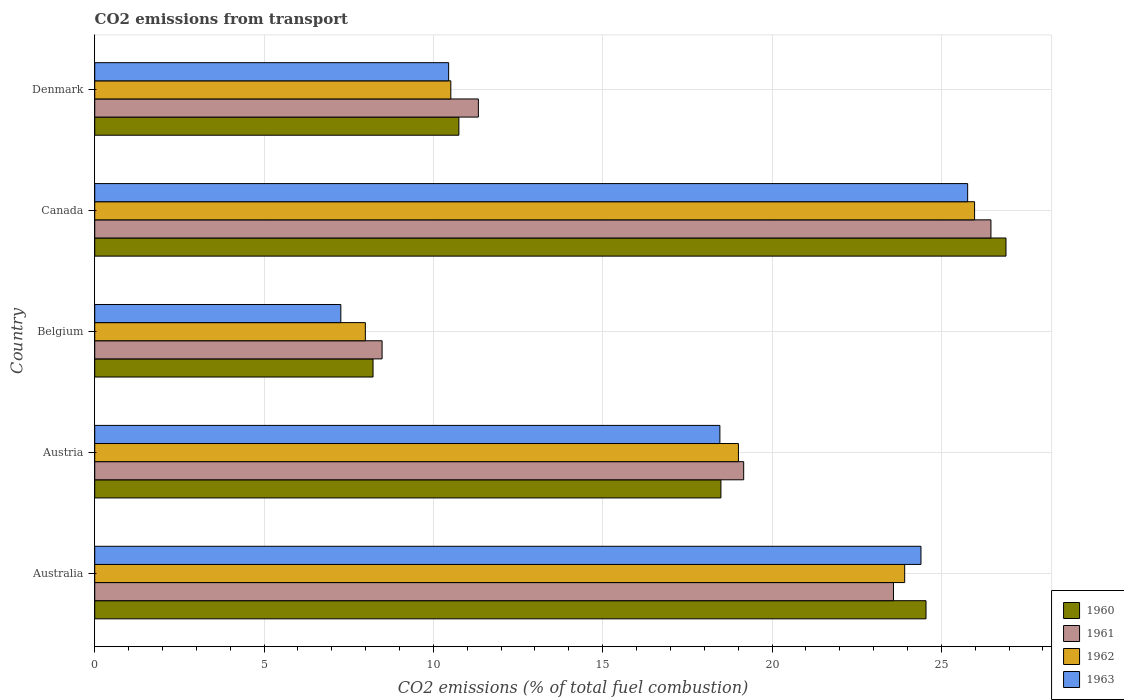How many groups of bars are there?
Your answer should be very brief. 5. Are the number of bars per tick equal to the number of legend labels?
Offer a terse response. Yes. Are the number of bars on each tick of the Y-axis equal?
Offer a terse response. Yes. How many bars are there on the 3rd tick from the top?
Provide a short and direct response. 4. What is the label of the 1st group of bars from the top?
Provide a succinct answer. Denmark. In how many cases, is the number of bars for a given country not equal to the number of legend labels?
Your answer should be compact. 0. What is the total CO2 emitted in 1961 in Australia?
Give a very brief answer. 23.59. Across all countries, what is the maximum total CO2 emitted in 1963?
Your answer should be very brief. 25.78. Across all countries, what is the minimum total CO2 emitted in 1960?
Ensure brevity in your answer.  8.22. In which country was the total CO2 emitted in 1962 maximum?
Provide a short and direct response. Canada. In which country was the total CO2 emitted in 1961 minimum?
Make the answer very short. Belgium. What is the total total CO2 emitted in 1962 in the graph?
Your answer should be very brief. 87.41. What is the difference between the total CO2 emitted in 1961 in Australia and that in Denmark?
Your answer should be very brief. 12.26. What is the difference between the total CO2 emitted in 1963 in Austria and the total CO2 emitted in 1961 in Denmark?
Offer a very short reply. 7.13. What is the average total CO2 emitted in 1962 per country?
Provide a short and direct response. 17.48. What is the difference between the total CO2 emitted in 1961 and total CO2 emitted in 1960 in Austria?
Your answer should be compact. 0.67. In how many countries, is the total CO2 emitted in 1960 greater than 6 ?
Keep it short and to the point. 5. What is the ratio of the total CO2 emitted in 1961 in Australia to that in Denmark?
Offer a terse response. 2.08. Is the total CO2 emitted in 1962 in Australia less than that in Denmark?
Keep it short and to the point. No. What is the difference between the highest and the second highest total CO2 emitted in 1963?
Your answer should be very brief. 1.38. What is the difference between the highest and the lowest total CO2 emitted in 1961?
Offer a very short reply. 17.98. Is the sum of the total CO2 emitted in 1960 in Australia and Austria greater than the maximum total CO2 emitted in 1961 across all countries?
Offer a terse response. Yes. What does the 4th bar from the top in Austria represents?
Your response must be concise. 1960. Is it the case that in every country, the sum of the total CO2 emitted in 1962 and total CO2 emitted in 1960 is greater than the total CO2 emitted in 1963?
Your response must be concise. Yes. How many bars are there?
Offer a very short reply. 20. Are all the bars in the graph horizontal?
Provide a short and direct response. Yes. How many countries are there in the graph?
Offer a very short reply. 5. How many legend labels are there?
Provide a succinct answer. 4. What is the title of the graph?
Ensure brevity in your answer.  CO2 emissions from transport. Does "1968" appear as one of the legend labels in the graph?
Your response must be concise. No. What is the label or title of the X-axis?
Give a very brief answer. CO2 emissions (% of total fuel combustion). What is the CO2 emissions (% of total fuel combustion) in 1960 in Australia?
Make the answer very short. 24.55. What is the CO2 emissions (% of total fuel combustion) of 1961 in Australia?
Give a very brief answer. 23.59. What is the CO2 emissions (% of total fuel combustion) in 1962 in Australia?
Ensure brevity in your answer.  23.92. What is the CO2 emissions (% of total fuel combustion) in 1963 in Australia?
Ensure brevity in your answer.  24.4. What is the CO2 emissions (% of total fuel combustion) of 1960 in Austria?
Provide a succinct answer. 18.49. What is the CO2 emissions (% of total fuel combustion) of 1961 in Austria?
Your answer should be compact. 19.16. What is the CO2 emissions (% of total fuel combustion) of 1962 in Austria?
Your answer should be compact. 19.01. What is the CO2 emissions (% of total fuel combustion) in 1963 in Austria?
Make the answer very short. 18.46. What is the CO2 emissions (% of total fuel combustion) of 1960 in Belgium?
Keep it short and to the point. 8.22. What is the CO2 emissions (% of total fuel combustion) of 1961 in Belgium?
Your answer should be very brief. 8.49. What is the CO2 emissions (% of total fuel combustion) in 1962 in Belgium?
Your answer should be compact. 7.99. What is the CO2 emissions (% of total fuel combustion) in 1963 in Belgium?
Offer a terse response. 7.27. What is the CO2 emissions (% of total fuel combustion) of 1960 in Canada?
Your response must be concise. 26.91. What is the CO2 emissions (% of total fuel combustion) in 1961 in Canada?
Offer a terse response. 26.46. What is the CO2 emissions (% of total fuel combustion) in 1962 in Canada?
Provide a succinct answer. 25.98. What is the CO2 emissions (% of total fuel combustion) of 1963 in Canada?
Make the answer very short. 25.78. What is the CO2 emissions (% of total fuel combustion) of 1960 in Denmark?
Give a very brief answer. 10.75. What is the CO2 emissions (% of total fuel combustion) in 1961 in Denmark?
Offer a terse response. 11.33. What is the CO2 emissions (% of total fuel combustion) of 1962 in Denmark?
Your answer should be very brief. 10.51. What is the CO2 emissions (% of total fuel combustion) in 1963 in Denmark?
Your answer should be very brief. 10.45. Across all countries, what is the maximum CO2 emissions (% of total fuel combustion) in 1960?
Keep it short and to the point. 26.91. Across all countries, what is the maximum CO2 emissions (% of total fuel combustion) in 1961?
Offer a terse response. 26.46. Across all countries, what is the maximum CO2 emissions (% of total fuel combustion) of 1962?
Offer a terse response. 25.98. Across all countries, what is the maximum CO2 emissions (% of total fuel combustion) of 1963?
Make the answer very short. 25.78. Across all countries, what is the minimum CO2 emissions (% of total fuel combustion) of 1960?
Your answer should be compact. 8.22. Across all countries, what is the minimum CO2 emissions (% of total fuel combustion) in 1961?
Keep it short and to the point. 8.49. Across all countries, what is the minimum CO2 emissions (% of total fuel combustion) of 1962?
Ensure brevity in your answer.  7.99. Across all countries, what is the minimum CO2 emissions (% of total fuel combustion) of 1963?
Keep it short and to the point. 7.27. What is the total CO2 emissions (% of total fuel combustion) of 1960 in the graph?
Offer a very short reply. 88.91. What is the total CO2 emissions (% of total fuel combustion) of 1961 in the graph?
Offer a terse response. 89.02. What is the total CO2 emissions (% of total fuel combustion) of 1962 in the graph?
Offer a very short reply. 87.41. What is the total CO2 emissions (% of total fuel combustion) in 1963 in the graph?
Offer a terse response. 86.35. What is the difference between the CO2 emissions (% of total fuel combustion) of 1960 in Australia and that in Austria?
Your response must be concise. 6.06. What is the difference between the CO2 emissions (% of total fuel combustion) of 1961 in Australia and that in Austria?
Give a very brief answer. 4.42. What is the difference between the CO2 emissions (% of total fuel combustion) in 1962 in Australia and that in Austria?
Offer a terse response. 4.91. What is the difference between the CO2 emissions (% of total fuel combustion) of 1963 in Australia and that in Austria?
Your response must be concise. 5.94. What is the difference between the CO2 emissions (% of total fuel combustion) in 1960 in Australia and that in Belgium?
Offer a terse response. 16.33. What is the difference between the CO2 emissions (% of total fuel combustion) in 1961 in Australia and that in Belgium?
Give a very brief answer. 15.1. What is the difference between the CO2 emissions (% of total fuel combustion) of 1962 in Australia and that in Belgium?
Offer a terse response. 15.93. What is the difference between the CO2 emissions (% of total fuel combustion) in 1963 in Australia and that in Belgium?
Keep it short and to the point. 17.13. What is the difference between the CO2 emissions (% of total fuel combustion) of 1960 in Australia and that in Canada?
Provide a short and direct response. -2.36. What is the difference between the CO2 emissions (% of total fuel combustion) in 1961 in Australia and that in Canada?
Keep it short and to the point. -2.88. What is the difference between the CO2 emissions (% of total fuel combustion) in 1962 in Australia and that in Canada?
Your response must be concise. -2.06. What is the difference between the CO2 emissions (% of total fuel combustion) in 1963 in Australia and that in Canada?
Keep it short and to the point. -1.38. What is the difference between the CO2 emissions (% of total fuel combustion) in 1960 in Australia and that in Denmark?
Make the answer very short. 13.79. What is the difference between the CO2 emissions (% of total fuel combustion) of 1961 in Australia and that in Denmark?
Give a very brief answer. 12.26. What is the difference between the CO2 emissions (% of total fuel combustion) in 1962 in Australia and that in Denmark?
Your answer should be compact. 13.4. What is the difference between the CO2 emissions (% of total fuel combustion) in 1963 in Australia and that in Denmark?
Your answer should be compact. 13.95. What is the difference between the CO2 emissions (% of total fuel combustion) of 1960 in Austria and that in Belgium?
Provide a succinct answer. 10.27. What is the difference between the CO2 emissions (% of total fuel combustion) of 1961 in Austria and that in Belgium?
Keep it short and to the point. 10.68. What is the difference between the CO2 emissions (% of total fuel combustion) in 1962 in Austria and that in Belgium?
Your response must be concise. 11.02. What is the difference between the CO2 emissions (% of total fuel combustion) of 1963 in Austria and that in Belgium?
Make the answer very short. 11.19. What is the difference between the CO2 emissions (% of total fuel combustion) of 1960 in Austria and that in Canada?
Provide a short and direct response. -8.42. What is the difference between the CO2 emissions (% of total fuel combustion) of 1961 in Austria and that in Canada?
Offer a terse response. -7.3. What is the difference between the CO2 emissions (% of total fuel combustion) in 1962 in Austria and that in Canada?
Keep it short and to the point. -6.97. What is the difference between the CO2 emissions (% of total fuel combustion) in 1963 in Austria and that in Canada?
Make the answer very short. -7.32. What is the difference between the CO2 emissions (% of total fuel combustion) of 1960 in Austria and that in Denmark?
Keep it short and to the point. 7.74. What is the difference between the CO2 emissions (% of total fuel combustion) in 1961 in Austria and that in Denmark?
Give a very brief answer. 7.83. What is the difference between the CO2 emissions (% of total fuel combustion) of 1962 in Austria and that in Denmark?
Make the answer very short. 8.49. What is the difference between the CO2 emissions (% of total fuel combustion) of 1963 in Austria and that in Denmark?
Offer a terse response. 8.01. What is the difference between the CO2 emissions (% of total fuel combustion) of 1960 in Belgium and that in Canada?
Your answer should be compact. -18.69. What is the difference between the CO2 emissions (% of total fuel combustion) in 1961 in Belgium and that in Canada?
Your response must be concise. -17.98. What is the difference between the CO2 emissions (% of total fuel combustion) of 1962 in Belgium and that in Canada?
Give a very brief answer. -17.99. What is the difference between the CO2 emissions (% of total fuel combustion) of 1963 in Belgium and that in Canada?
Keep it short and to the point. -18.51. What is the difference between the CO2 emissions (% of total fuel combustion) in 1960 in Belgium and that in Denmark?
Provide a succinct answer. -2.53. What is the difference between the CO2 emissions (% of total fuel combustion) of 1961 in Belgium and that in Denmark?
Your response must be concise. -2.84. What is the difference between the CO2 emissions (% of total fuel combustion) in 1962 in Belgium and that in Denmark?
Provide a succinct answer. -2.52. What is the difference between the CO2 emissions (% of total fuel combustion) in 1963 in Belgium and that in Denmark?
Provide a succinct answer. -3.18. What is the difference between the CO2 emissions (% of total fuel combustion) of 1960 in Canada and that in Denmark?
Your response must be concise. 16.16. What is the difference between the CO2 emissions (% of total fuel combustion) in 1961 in Canada and that in Denmark?
Keep it short and to the point. 15.13. What is the difference between the CO2 emissions (% of total fuel combustion) of 1962 in Canada and that in Denmark?
Your answer should be very brief. 15.47. What is the difference between the CO2 emissions (% of total fuel combustion) in 1963 in Canada and that in Denmark?
Offer a very short reply. 15.33. What is the difference between the CO2 emissions (% of total fuel combustion) in 1960 in Australia and the CO2 emissions (% of total fuel combustion) in 1961 in Austria?
Your response must be concise. 5.38. What is the difference between the CO2 emissions (% of total fuel combustion) in 1960 in Australia and the CO2 emissions (% of total fuel combustion) in 1962 in Austria?
Offer a very short reply. 5.54. What is the difference between the CO2 emissions (% of total fuel combustion) of 1960 in Australia and the CO2 emissions (% of total fuel combustion) of 1963 in Austria?
Offer a very short reply. 6.09. What is the difference between the CO2 emissions (% of total fuel combustion) in 1961 in Australia and the CO2 emissions (% of total fuel combustion) in 1962 in Austria?
Keep it short and to the point. 4.58. What is the difference between the CO2 emissions (% of total fuel combustion) of 1961 in Australia and the CO2 emissions (% of total fuel combustion) of 1963 in Austria?
Offer a very short reply. 5.13. What is the difference between the CO2 emissions (% of total fuel combustion) of 1962 in Australia and the CO2 emissions (% of total fuel combustion) of 1963 in Austria?
Offer a very short reply. 5.46. What is the difference between the CO2 emissions (% of total fuel combustion) of 1960 in Australia and the CO2 emissions (% of total fuel combustion) of 1961 in Belgium?
Keep it short and to the point. 16.06. What is the difference between the CO2 emissions (% of total fuel combustion) in 1960 in Australia and the CO2 emissions (% of total fuel combustion) in 1962 in Belgium?
Give a very brief answer. 16.56. What is the difference between the CO2 emissions (% of total fuel combustion) of 1960 in Australia and the CO2 emissions (% of total fuel combustion) of 1963 in Belgium?
Your answer should be compact. 17.28. What is the difference between the CO2 emissions (% of total fuel combustion) of 1961 in Australia and the CO2 emissions (% of total fuel combustion) of 1962 in Belgium?
Your response must be concise. 15.59. What is the difference between the CO2 emissions (% of total fuel combustion) in 1961 in Australia and the CO2 emissions (% of total fuel combustion) in 1963 in Belgium?
Make the answer very short. 16.32. What is the difference between the CO2 emissions (% of total fuel combustion) in 1962 in Australia and the CO2 emissions (% of total fuel combustion) in 1963 in Belgium?
Ensure brevity in your answer.  16.65. What is the difference between the CO2 emissions (% of total fuel combustion) in 1960 in Australia and the CO2 emissions (% of total fuel combustion) in 1961 in Canada?
Ensure brevity in your answer.  -1.92. What is the difference between the CO2 emissions (% of total fuel combustion) of 1960 in Australia and the CO2 emissions (% of total fuel combustion) of 1962 in Canada?
Provide a succinct answer. -1.43. What is the difference between the CO2 emissions (% of total fuel combustion) of 1960 in Australia and the CO2 emissions (% of total fuel combustion) of 1963 in Canada?
Provide a succinct answer. -1.23. What is the difference between the CO2 emissions (% of total fuel combustion) of 1961 in Australia and the CO2 emissions (% of total fuel combustion) of 1962 in Canada?
Make the answer very short. -2.4. What is the difference between the CO2 emissions (% of total fuel combustion) in 1961 in Australia and the CO2 emissions (% of total fuel combustion) in 1963 in Canada?
Provide a succinct answer. -2.19. What is the difference between the CO2 emissions (% of total fuel combustion) in 1962 in Australia and the CO2 emissions (% of total fuel combustion) in 1963 in Canada?
Ensure brevity in your answer.  -1.86. What is the difference between the CO2 emissions (% of total fuel combustion) of 1960 in Australia and the CO2 emissions (% of total fuel combustion) of 1961 in Denmark?
Make the answer very short. 13.22. What is the difference between the CO2 emissions (% of total fuel combustion) in 1960 in Australia and the CO2 emissions (% of total fuel combustion) in 1962 in Denmark?
Provide a succinct answer. 14.03. What is the difference between the CO2 emissions (% of total fuel combustion) in 1960 in Australia and the CO2 emissions (% of total fuel combustion) in 1963 in Denmark?
Ensure brevity in your answer.  14.1. What is the difference between the CO2 emissions (% of total fuel combustion) in 1961 in Australia and the CO2 emissions (% of total fuel combustion) in 1962 in Denmark?
Your response must be concise. 13.07. What is the difference between the CO2 emissions (% of total fuel combustion) of 1961 in Australia and the CO2 emissions (% of total fuel combustion) of 1963 in Denmark?
Your answer should be compact. 13.13. What is the difference between the CO2 emissions (% of total fuel combustion) of 1962 in Australia and the CO2 emissions (% of total fuel combustion) of 1963 in Denmark?
Your answer should be compact. 13.47. What is the difference between the CO2 emissions (% of total fuel combustion) of 1960 in Austria and the CO2 emissions (% of total fuel combustion) of 1961 in Belgium?
Offer a terse response. 10. What is the difference between the CO2 emissions (% of total fuel combustion) in 1960 in Austria and the CO2 emissions (% of total fuel combustion) in 1962 in Belgium?
Give a very brief answer. 10.5. What is the difference between the CO2 emissions (% of total fuel combustion) of 1960 in Austria and the CO2 emissions (% of total fuel combustion) of 1963 in Belgium?
Provide a succinct answer. 11.22. What is the difference between the CO2 emissions (% of total fuel combustion) of 1961 in Austria and the CO2 emissions (% of total fuel combustion) of 1962 in Belgium?
Offer a very short reply. 11.17. What is the difference between the CO2 emissions (% of total fuel combustion) of 1961 in Austria and the CO2 emissions (% of total fuel combustion) of 1963 in Belgium?
Keep it short and to the point. 11.9. What is the difference between the CO2 emissions (% of total fuel combustion) in 1962 in Austria and the CO2 emissions (% of total fuel combustion) in 1963 in Belgium?
Provide a short and direct response. 11.74. What is the difference between the CO2 emissions (% of total fuel combustion) in 1960 in Austria and the CO2 emissions (% of total fuel combustion) in 1961 in Canada?
Provide a succinct answer. -7.97. What is the difference between the CO2 emissions (% of total fuel combustion) in 1960 in Austria and the CO2 emissions (% of total fuel combustion) in 1962 in Canada?
Provide a succinct answer. -7.49. What is the difference between the CO2 emissions (% of total fuel combustion) of 1960 in Austria and the CO2 emissions (% of total fuel combustion) of 1963 in Canada?
Your answer should be compact. -7.29. What is the difference between the CO2 emissions (% of total fuel combustion) in 1961 in Austria and the CO2 emissions (% of total fuel combustion) in 1962 in Canada?
Give a very brief answer. -6.82. What is the difference between the CO2 emissions (% of total fuel combustion) of 1961 in Austria and the CO2 emissions (% of total fuel combustion) of 1963 in Canada?
Offer a very short reply. -6.61. What is the difference between the CO2 emissions (% of total fuel combustion) in 1962 in Austria and the CO2 emissions (% of total fuel combustion) in 1963 in Canada?
Give a very brief answer. -6.77. What is the difference between the CO2 emissions (% of total fuel combustion) of 1960 in Austria and the CO2 emissions (% of total fuel combustion) of 1961 in Denmark?
Your answer should be very brief. 7.16. What is the difference between the CO2 emissions (% of total fuel combustion) in 1960 in Austria and the CO2 emissions (% of total fuel combustion) in 1962 in Denmark?
Give a very brief answer. 7.98. What is the difference between the CO2 emissions (% of total fuel combustion) in 1960 in Austria and the CO2 emissions (% of total fuel combustion) in 1963 in Denmark?
Make the answer very short. 8.04. What is the difference between the CO2 emissions (% of total fuel combustion) of 1961 in Austria and the CO2 emissions (% of total fuel combustion) of 1962 in Denmark?
Offer a very short reply. 8.65. What is the difference between the CO2 emissions (% of total fuel combustion) of 1961 in Austria and the CO2 emissions (% of total fuel combustion) of 1963 in Denmark?
Make the answer very short. 8.71. What is the difference between the CO2 emissions (% of total fuel combustion) of 1962 in Austria and the CO2 emissions (% of total fuel combustion) of 1963 in Denmark?
Give a very brief answer. 8.56. What is the difference between the CO2 emissions (% of total fuel combustion) in 1960 in Belgium and the CO2 emissions (% of total fuel combustion) in 1961 in Canada?
Ensure brevity in your answer.  -18.25. What is the difference between the CO2 emissions (% of total fuel combustion) of 1960 in Belgium and the CO2 emissions (% of total fuel combustion) of 1962 in Canada?
Your response must be concise. -17.76. What is the difference between the CO2 emissions (% of total fuel combustion) of 1960 in Belgium and the CO2 emissions (% of total fuel combustion) of 1963 in Canada?
Offer a very short reply. -17.56. What is the difference between the CO2 emissions (% of total fuel combustion) in 1961 in Belgium and the CO2 emissions (% of total fuel combustion) in 1962 in Canada?
Keep it short and to the point. -17.5. What is the difference between the CO2 emissions (% of total fuel combustion) in 1961 in Belgium and the CO2 emissions (% of total fuel combustion) in 1963 in Canada?
Keep it short and to the point. -17.29. What is the difference between the CO2 emissions (% of total fuel combustion) of 1962 in Belgium and the CO2 emissions (% of total fuel combustion) of 1963 in Canada?
Your answer should be compact. -17.79. What is the difference between the CO2 emissions (% of total fuel combustion) of 1960 in Belgium and the CO2 emissions (% of total fuel combustion) of 1961 in Denmark?
Offer a very short reply. -3.11. What is the difference between the CO2 emissions (% of total fuel combustion) of 1960 in Belgium and the CO2 emissions (% of total fuel combustion) of 1962 in Denmark?
Your answer should be very brief. -2.3. What is the difference between the CO2 emissions (% of total fuel combustion) in 1960 in Belgium and the CO2 emissions (% of total fuel combustion) in 1963 in Denmark?
Your response must be concise. -2.23. What is the difference between the CO2 emissions (% of total fuel combustion) in 1961 in Belgium and the CO2 emissions (% of total fuel combustion) in 1962 in Denmark?
Keep it short and to the point. -2.03. What is the difference between the CO2 emissions (% of total fuel combustion) of 1961 in Belgium and the CO2 emissions (% of total fuel combustion) of 1963 in Denmark?
Offer a terse response. -1.96. What is the difference between the CO2 emissions (% of total fuel combustion) in 1962 in Belgium and the CO2 emissions (% of total fuel combustion) in 1963 in Denmark?
Ensure brevity in your answer.  -2.46. What is the difference between the CO2 emissions (% of total fuel combustion) in 1960 in Canada and the CO2 emissions (% of total fuel combustion) in 1961 in Denmark?
Offer a terse response. 15.58. What is the difference between the CO2 emissions (% of total fuel combustion) of 1960 in Canada and the CO2 emissions (% of total fuel combustion) of 1962 in Denmark?
Provide a short and direct response. 16.39. What is the difference between the CO2 emissions (% of total fuel combustion) in 1960 in Canada and the CO2 emissions (% of total fuel combustion) in 1963 in Denmark?
Offer a terse response. 16.46. What is the difference between the CO2 emissions (% of total fuel combustion) of 1961 in Canada and the CO2 emissions (% of total fuel combustion) of 1962 in Denmark?
Offer a terse response. 15.95. What is the difference between the CO2 emissions (% of total fuel combustion) of 1961 in Canada and the CO2 emissions (% of total fuel combustion) of 1963 in Denmark?
Provide a short and direct response. 16.01. What is the difference between the CO2 emissions (% of total fuel combustion) of 1962 in Canada and the CO2 emissions (% of total fuel combustion) of 1963 in Denmark?
Keep it short and to the point. 15.53. What is the average CO2 emissions (% of total fuel combustion) of 1960 per country?
Offer a terse response. 17.78. What is the average CO2 emissions (% of total fuel combustion) in 1961 per country?
Give a very brief answer. 17.8. What is the average CO2 emissions (% of total fuel combustion) in 1962 per country?
Your answer should be very brief. 17.48. What is the average CO2 emissions (% of total fuel combustion) of 1963 per country?
Ensure brevity in your answer.  17.27. What is the difference between the CO2 emissions (% of total fuel combustion) of 1960 and CO2 emissions (% of total fuel combustion) of 1961 in Australia?
Offer a very short reply. 0.96. What is the difference between the CO2 emissions (% of total fuel combustion) in 1960 and CO2 emissions (% of total fuel combustion) in 1962 in Australia?
Provide a short and direct response. 0.63. What is the difference between the CO2 emissions (% of total fuel combustion) of 1960 and CO2 emissions (% of total fuel combustion) of 1963 in Australia?
Provide a short and direct response. 0.15. What is the difference between the CO2 emissions (% of total fuel combustion) in 1961 and CO2 emissions (% of total fuel combustion) in 1962 in Australia?
Your answer should be compact. -0.33. What is the difference between the CO2 emissions (% of total fuel combustion) of 1961 and CO2 emissions (% of total fuel combustion) of 1963 in Australia?
Provide a short and direct response. -0.81. What is the difference between the CO2 emissions (% of total fuel combustion) of 1962 and CO2 emissions (% of total fuel combustion) of 1963 in Australia?
Provide a short and direct response. -0.48. What is the difference between the CO2 emissions (% of total fuel combustion) in 1960 and CO2 emissions (% of total fuel combustion) in 1961 in Austria?
Provide a succinct answer. -0.67. What is the difference between the CO2 emissions (% of total fuel combustion) in 1960 and CO2 emissions (% of total fuel combustion) in 1962 in Austria?
Offer a terse response. -0.52. What is the difference between the CO2 emissions (% of total fuel combustion) in 1960 and CO2 emissions (% of total fuel combustion) in 1963 in Austria?
Ensure brevity in your answer.  0.03. What is the difference between the CO2 emissions (% of total fuel combustion) in 1961 and CO2 emissions (% of total fuel combustion) in 1962 in Austria?
Provide a succinct answer. 0.15. What is the difference between the CO2 emissions (% of total fuel combustion) in 1961 and CO2 emissions (% of total fuel combustion) in 1963 in Austria?
Provide a short and direct response. 0.7. What is the difference between the CO2 emissions (% of total fuel combustion) of 1962 and CO2 emissions (% of total fuel combustion) of 1963 in Austria?
Give a very brief answer. 0.55. What is the difference between the CO2 emissions (% of total fuel combustion) of 1960 and CO2 emissions (% of total fuel combustion) of 1961 in Belgium?
Make the answer very short. -0.27. What is the difference between the CO2 emissions (% of total fuel combustion) of 1960 and CO2 emissions (% of total fuel combustion) of 1962 in Belgium?
Your response must be concise. 0.23. What is the difference between the CO2 emissions (% of total fuel combustion) in 1960 and CO2 emissions (% of total fuel combustion) in 1963 in Belgium?
Your answer should be compact. 0.95. What is the difference between the CO2 emissions (% of total fuel combustion) in 1961 and CO2 emissions (% of total fuel combustion) in 1962 in Belgium?
Offer a terse response. 0.49. What is the difference between the CO2 emissions (% of total fuel combustion) in 1961 and CO2 emissions (% of total fuel combustion) in 1963 in Belgium?
Your answer should be very brief. 1.22. What is the difference between the CO2 emissions (% of total fuel combustion) in 1962 and CO2 emissions (% of total fuel combustion) in 1963 in Belgium?
Keep it short and to the point. 0.72. What is the difference between the CO2 emissions (% of total fuel combustion) in 1960 and CO2 emissions (% of total fuel combustion) in 1961 in Canada?
Keep it short and to the point. 0.44. What is the difference between the CO2 emissions (% of total fuel combustion) in 1960 and CO2 emissions (% of total fuel combustion) in 1962 in Canada?
Ensure brevity in your answer.  0.93. What is the difference between the CO2 emissions (% of total fuel combustion) in 1960 and CO2 emissions (% of total fuel combustion) in 1963 in Canada?
Make the answer very short. 1.13. What is the difference between the CO2 emissions (% of total fuel combustion) in 1961 and CO2 emissions (% of total fuel combustion) in 1962 in Canada?
Your answer should be compact. 0.48. What is the difference between the CO2 emissions (% of total fuel combustion) in 1961 and CO2 emissions (% of total fuel combustion) in 1963 in Canada?
Make the answer very short. 0.69. What is the difference between the CO2 emissions (% of total fuel combustion) in 1962 and CO2 emissions (% of total fuel combustion) in 1963 in Canada?
Give a very brief answer. 0.2. What is the difference between the CO2 emissions (% of total fuel combustion) of 1960 and CO2 emissions (% of total fuel combustion) of 1961 in Denmark?
Give a very brief answer. -0.58. What is the difference between the CO2 emissions (% of total fuel combustion) of 1960 and CO2 emissions (% of total fuel combustion) of 1962 in Denmark?
Ensure brevity in your answer.  0.24. What is the difference between the CO2 emissions (% of total fuel combustion) of 1960 and CO2 emissions (% of total fuel combustion) of 1963 in Denmark?
Offer a very short reply. 0.3. What is the difference between the CO2 emissions (% of total fuel combustion) in 1961 and CO2 emissions (% of total fuel combustion) in 1962 in Denmark?
Your answer should be compact. 0.81. What is the difference between the CO2 emissions (% of total fuel combustion) in 1961 and CO2 emissions (% of total fuel combustion) in 1963 in Denmark?
Give a very brief answer. 0.88. What is the difference between the CO2 emissions (% of total fuel combustion) in 1962 and CO2 emissions (% of total fuel combustion) in 1963 in Denmark?
Your answer should be very brief. 0.06. What is the ratio of the CO2 emissions (% of total fuel combustion) of 1960 in Australia to that in Austria?
Make the answer very short. 1.33. What is the ratio of the CO2 emissions (% of total fuel combustion) of 1961 in Australia to that in Austria?
Offer a terse response. 1.23. What is the ratio of the CO2 emissions (% of total fuel combustion) in 1962 in Australia to that in Austria?
Your answer should be very brief. 1.26. What is the ratio of the CO2 emissions (% of total fuel combustion) of 1963 in Australia to that in Austria?
Keep it short and to the point. 1.32. What is the ratio of the CO2 emissions (% of total fuel combustion) of 1960 in Australia to that in Belgium?
Ensure brevity in your answer.  2.99. What is the ratio of the CO2 emissions (% of total fuel combustion) of 1961 in Australia to that in Belgium?
Provide a succinct answer. 2.78. What is the ratio of the CO2 emissions (% of total fuel combustion) in 1962 in Australia to that in Belgium?
Offer a terse response. 2.99. What is the ratio of the CO2 emissions (% of total fuel combustion) of 1963 in Australia to that in Belgium?
Your answer should be compact. 3.36. What is the ratio of the CO2 emissions (% of total fuel combustion) in 1960 in Australia to that in Canada?
Offer a very short reply. 0.91. What is the ratio of the CO2 emissions (% of total fuel combustion) in 1961 in Australia to that in Canada?
Offer a very short reply. 0.89. What is the ratio of the CO2 emissions (% of total fuel combustion) of 1962 in Australia to that in Canada?
Provide a short and direct response. 0.92. What is the ratio of the CO2 emissions (% of total fuel combustion) in 1963 in Australia to that in Canada?
Offer a terse response. 0.95. What is the ratio of the CO2 emissions (% of total fuel combustion) of 1960 in Australia to that in Denmark?
Your answer should be very brief. 2.28. What is the ratio of the CO2 emissions (% of total fuel combustion) of 1961 in Australia to that in Denmark?
Provide a succinct answer. 2.08. What is the ratio of the CO2 emissions (% of total fuel combustion) in 1962 in Australia to that in Denmark?
Give a very brief answer. 2.27. What is the ratio of the CO2 emissions (% of total fuel combustion) of 1963 in Australia to that in Denmark?
Give a very brief answer. 2.33. What is the ratio of the CO2 emissions (% of total fuel combustion) of 1960 in Austria to that in Belgium?
Provide a succinct answer. 2.25. What is the ratio of the CO2 emissions (% of total fuel combustion) of 1961 in Austria to that in Belgium?
Offer a terse response. 2.26. What is the ratio of the CO2 emissions (% of total fuel combustion) of 1962 in Austria to that in Belgium?
Ensure brevity in your answer.  2.38. What is the ratio of the CO2 emissions (% of total fuel combustion) in 1963 in Austria to that in Belgium?
Keep it short and to the point. 2.54. What is the ratio of the CO2 emissions (% of total fuel combustion) of 1960 in Austria to that in Canada?
Your response must be concise. 0.69. What is the ratio of the CO2 emissions (% of total fuel combustion) of 1961 in Austria to that in Canada?
Provide a short and direct response. 0.72. What is the ratio of the CO2 emissions (% of total fuel combustion) in 1962 in Austria to that in Canada?
Ensure brevity in your answer.  0.73. What is the ratio of the CO2 emissions (% of total fuel combustion) in 1963 in Austria to that in Canada?
Your answer should be compact. 0.72. What is the ratio of the CO2 emissions (% of total fuel combustion) in 1960 in Austria to that in Denmark?
Your answer should be compact. 1.72. What is the ratio of the CO2 emissions (% of total fuel combustion) of 1961 in Austria to that in Denmark?
Provide a succinct answer. 1.69. What is the ratio of the CO2 emissions (% of total fuel combustion) of 1962 in Austria to that in Denmark?
Make the answer very short. 1.81. What is the ratio of the CO2 emissions (% of total fuel combustion) in 1963 in Austria to that in Denmark?
Offer a very short reply. 1.77. What is the ratio of the CO2 emissions (% of total fuel combustion) in 1960 in Belgium to that in Canada?
Give a very brief answer. 0.31. What is the ratio of the CO2 emissions (% of total fuel combustion) in 1961 in Belgium to that in Canada?
Your answer should be compact. 0.32. What is the ratio of the CO2 emissions (% of total fuel combustion) of 1962 in Belgium to that in Canada?
Make the answer very short. 0.31. What is the ratio of the CO2 emissions (% of total fuel combustion) in 1963 in Belgium to that in Canada?
Provide a short and direct response. 0.28. What is the ratio of the CO2 emissions (% of total fuel combustion) in 1960 in Belgium to that in Denmark?
Your response must be concise. 0.76. What is the ratio of the CO2 emissions (% of total fuel combustion) in 1961 in Belgium to that in Denmark?
Your response must be concise. 0.75. What is the ratio of the CO2 emissions (% of total fuel combustion) in 1962 in Belgium to that in Denmark?
Your answer should be compact. 0.76. What is the ratio of the CO2 emissions (% of total fuel combustion) of 1963 in Belgium to that in Denmark?
Offer a very short reply. 0.7. What is the ratio of the CO2 emissions (% of total fuel combustion) of 1960 in Canada to that in Denmark?
Ensure brevity in your answer.  2.5. What is the ratio of the CO2 emissions (% of total fuel combustion) in 1961 in Canada to that in Denmark?
Your response must be concise. 2.34. What is the ratio of the CO2 emissions (% of total fuel combustion) of 1962 in Canada to that in Denmark?
Provide a short and direct response. 2.47. What is the ratio of the CO2 emissions (% of total fuel combustion) of 1963 in Canada to that in Denmark?
Give a very brief answer. 2.47. What is the difference between the highest and the second highest CO2 emissions (% of total fuel combustion) in 1960?
Provide a short and direct response. 2.36. What is the difference between the highest and the second highest CO2 emissions (% of total fuel combustion) of 1961?
Offer a terse response. 2.88. What is the difference between the highest and the second highest CO2 emissions (% of total fuel combustion) of 1962?
Provide a succinct answer. 2.06. What is the difference between the highest and the second highest CO2 emissions (% of total fuel combustion) in 1963?
Your answer should be compact. 1.38. What is the difference between the highest and the lowest CO2 emissions (% of total fuel combustion) of 1960?
Your response must be concise. 18.69. What is the difference between the highest and the lowest CO2 emissions (% of total fuel combustion) in 1961?
Give a very brief answer. 17.98. What is the difference between the highest and the lowest CO2 emissions (% of total fuel combustion) of 1962?
Your answer should be compact. 17.99. What is the difference between the highest and the lowest CO2 emissions (% of total fuel combustion) of 1963?
Give a very brief answer. 18.51. 